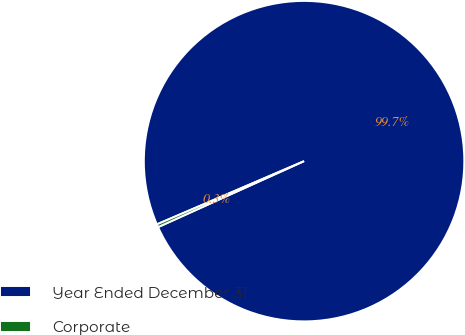<chart> <loc_0><loc_0><loc_500><loc_500><pie_chart><fcel>Year Ended December 31<fcel>Corporate<nl><fcel>99.7%<fcel>0.3%<nl></chart> 